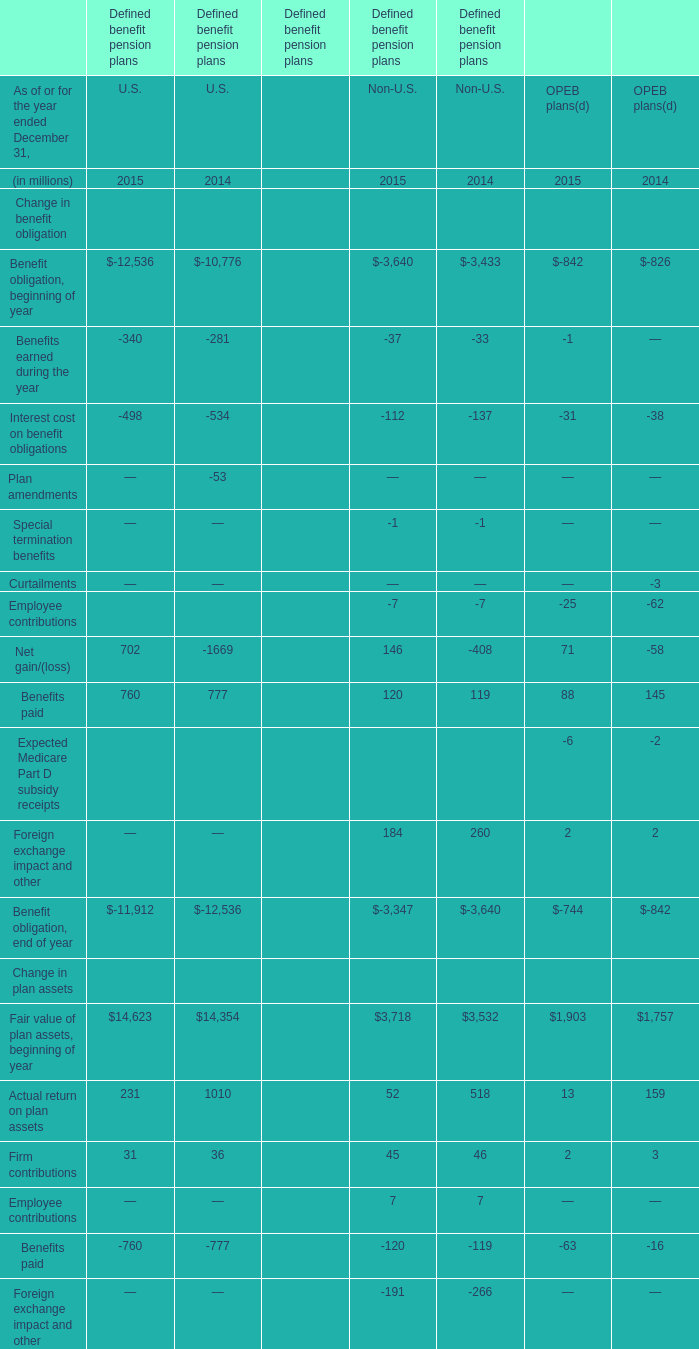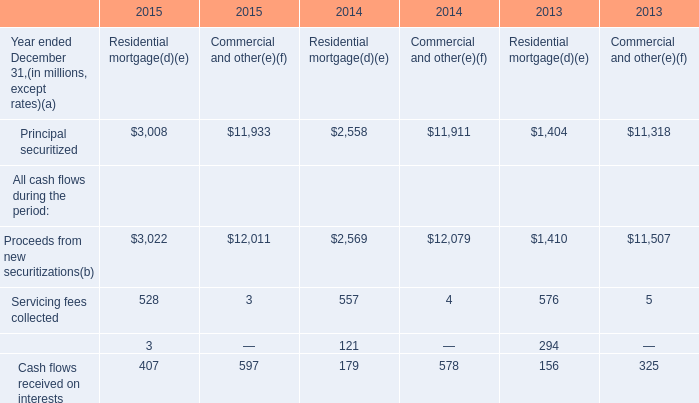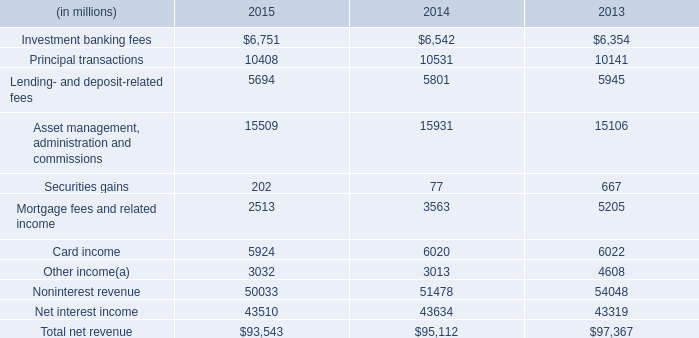what's the total amount of Principal securitized of 2014 Commercial and other, Net interest income of 2013, and Benefit obligation, end of year of Defined benefit pension plans U.S. 2015 ? 
Computations: ((11911.0 + 43319.0) + 11912.0)
Answer: 67142.0. 